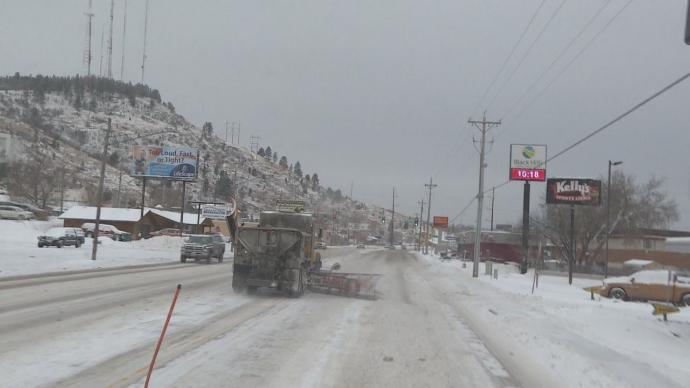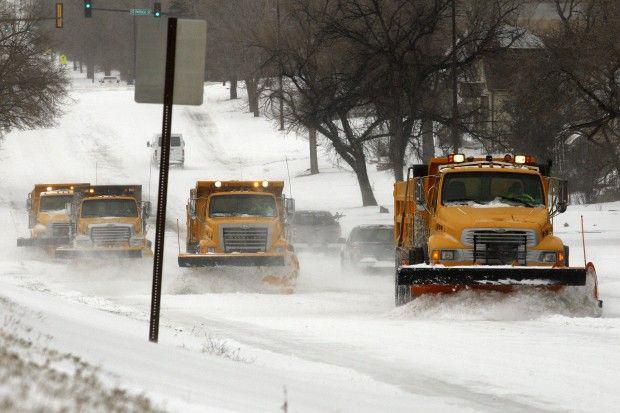The first image is the image on the left, the second image is the image on the right. Evaluate the accuracy of this statement regarding the images: "There is a line of plows in the right image and a single plow in the left.". Is it true? Answer yes or no. Yes. The first image is the image on the left, the second image is the image on the right. Assess this claim about the two images: "Both images show the front side of a snow plow.". Correct or not? Answer yes or no. No. 